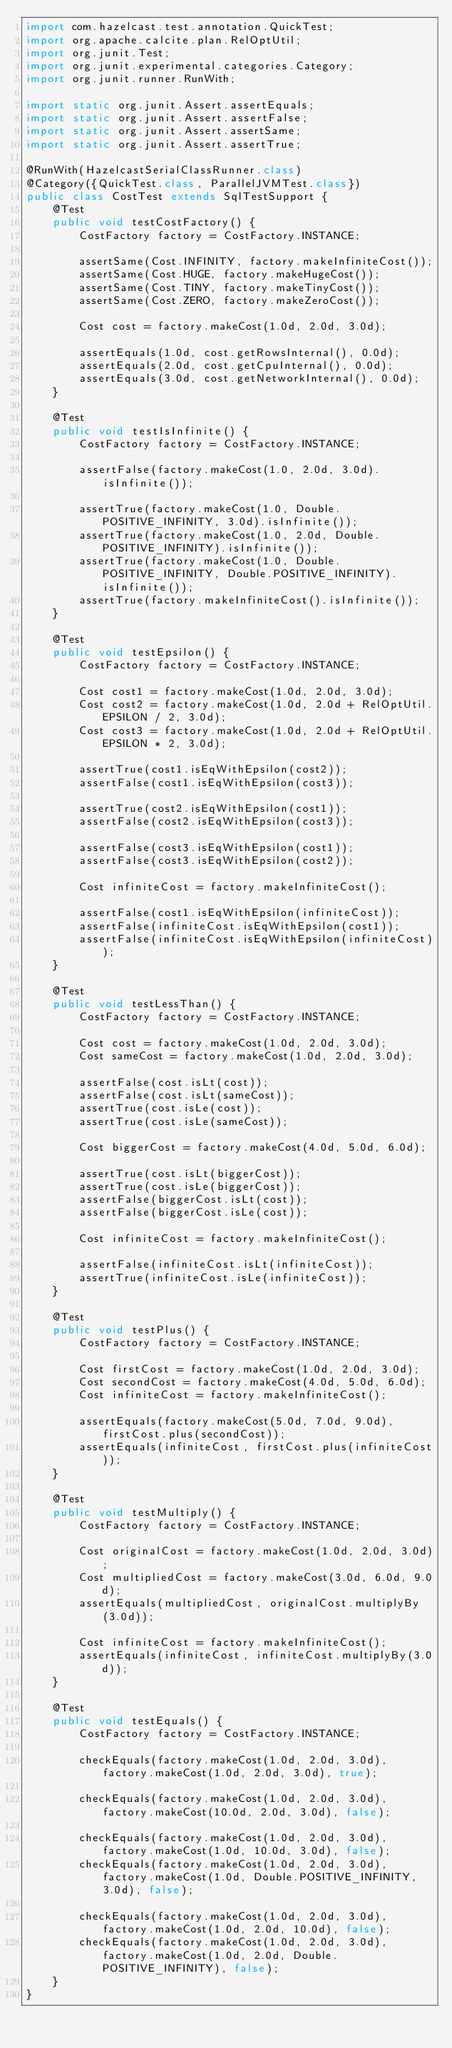<code> <loc_0><loc_0><loc_500><loc_500><_Java_>import com.hazelcast.test.annotation.QuickTest;
import org.apache.calcite.plan.RelOptUtil;
import org.junit.Test;
import org.junit.experimental.categories.Category;
import org.junit.runner.RunWith;

import static org.junit.Assert.assertEquals;
import static org.junit.Assert.assertFalse;
import static org.junit.Assert.assertSame;
import static org.junit.Assert.assertTrue;

@RunWith(HazelcastSerialClassRunner.class)
@Category({QuickTest.class, ParallelJVMTest.class})
public class CostTest extends SqlTestSupport {
    @Test
    public void testCostFactory() {
        CostFactory factory = CostFactory.INSTANCE;

        assertSame(Cost.INFINITY, factory.makeInfiniteCost());
        assertSame(Cost.HUGE, factory.makeHugeCost());
        assertSame(Cost.TINY, factory.makeTinyCost());
        assertSame(Cost.ZERO, factory.makeZeroCost());

        Cost cost = factory.makeCost(1.0d, 2.0d, 3.0d);

        assertEquals(1.0d, cost.getRowsInternal(), 0.0d);
        assertEquals(2.0d, cost.getCpuInternal(), 0.0d);
        assertEquals(3.0d, cost.getNetworkInternal(), 0.0d);
    }

    @Test
    public void testIsInfinite() {
        CostFactory factory = CostFactory.INSTANCE;

        assertFalse(factory.makeCost(1.0, 2.0d, 3.0d).isInfinite());

        assertTrue(factory.makeCost(1.0, Double.POSITIVE_INFINITY, 3.0d).isInfinite());
        assertTrue(factory.makeCost(1.0, 2.0d, Double.POSITIVE_INFINITY).isInfinite());
        assertTrue(factory.makeCost(1.0, Double.POSITIVE_INFINITY, Double.POSITIVE_INFINITY).isInfinite());
        assertTrue(factory.makeInfiniteCost().isInfinite());
    }

    @Test
    public void testEpsilon() {
        CostFactory factory = CostFactory.INSTANCE;

        Cost cost1 = factory.makeCost(1.0d, 2.0d, 3.0d);
        Cost cost2 = factory.makeCost(1.0d, 2.0d + RelOptUtil.EPSILON / 2, 3.0d);
        Cost cost3 = factory.makeCost(1.0d, 2.0d + RelOptUtil.EPSILON * 2, 3.0d);

        assertTrue(cost1.isEqWithEpsilon(cost2));
        assertFalse(cost1.isEqWithEpsilon(cost3));

        assertTrue(cost2.isEqWithEpsilon(cost1));
        assertFalse(cost2.isEqWithEpsilon(cost3));

        assertFalse(cost3.isEqWithEpsilon(cost1));
        assertFalse(cost3.isEqWithEpsilon(cost2));

        Cost infiniteCost = factory.makeInfiniteCost();

        assertFalse(cost1.isEqWithEpsilon(infiniteCost));
        assertFalse(infiniteCost.isEqWithEpsilon(cost1));
        assertFalse(infiniteCost.isEqWithEpsilon(infiniteCost));
    }

    @Test
    public void testLessThan() {
        CostFactory factory = CostFactory.INSTANCE;

        Cost cost = factory.makeCost(1.0d, 2.0d, 3.0d);
        Cost sameCost = factory.makeCost(1.0d, 2.0d, 3.0d);

        assertFalse(cost.isLt(cost));
        assertFalse(cost.isLt(sameCost));
        assertTrue(cost.isLe(cost));
        assertTrue(cost.isLe(sameCost));

        Cost biggerCost = factory.makeCost(4.0d, 5.0d, 6.0d);

        assertTrue(cost.isLt(biggerCost));
        assertTrue(cost.isLe(biggerCost));
        assertFalse(biggerCost.isLt(cost));
        assertFalse(biggerCost.isLe(cost));

        Cost infiniteCost = factory.makeInfiniteCost();

        assertFalse(infiniteCost.isLt(infiniteCost));
        assertTrue(infiniteCost.isLe(infiniteCost));
    }

    @Test
    public void testPlus() {
        CostFactory factory = CostFactory.INSTANCE;

        Cost firstCost = factory.makeCost(1.0d, 2.0d, 3.0d);
        Cost secondCost = factory.makeCost(4.0d, 5.0d, 6.0d);
        Cost infiniteCost = factory.makeInfiniteCost();

        assertEquals(factory.makeCost(5.0d, 7.0d, 9.0d), firstCost.plus(secondCost));
        assertEquals(infiniteCost, firstCost.plus(infiniteCost));
    }

    @Test
    public void testMultiply() {
        CostFactory factory = CostFactory.INSTANCE;

        Cost originalCost = factory.makeCost(1.0d, 2.0d, 3.0d);
        Cost multipliedCost = factory.makeCost(3.0d, 6.0d, 9.0d);
        assertEquals(multipliedCost, originalCost.multiplyBy(3.0d));

        Cost infiniteCost = factory.makeInfiniteCost();
        assertEquals(infiniteCost, infiniteCost.multiplyBy(3.0d));
    }

    @Test
    public void testEquals() {
        CostFactory factory = CostFactory.INSTANCE;

        checkEquals(factory.makeCost(1.0d, 2.0d, 3.0d), factory.makeCost(1.0d, 2.0d, 3.0d), true);

        checkEquals(factory.makeCost(1.0d, 2.0d, 3.0d), factory.makeCost(10.0d, 2.0d, 3.0d), false);

        checkEquals(factory.makeCost(1.0d, 2.0d, 3.0d), factory.makeCost(1.0d, 10.0d, 3.0d), false);
        checkEquals(factory.makeCost(1.0d, 2.0d, 3.0d), factory.makeCost(1.0d, Double.POSITIVE_INFINITY, 3.0d), false);

        checkEquals(factory.makeCost(1.0d, 2.0d, 3.0d), factory.makeCost(1.0d, 2.0d, 10.0d), false);
        checkEquals(factory.makeCost(1.0d, 2.0d, 3.0d), factory.makeCost(1.0d, 2.0d, Double.POSITIVE_INFINITY), false);
    }
}
</code> 